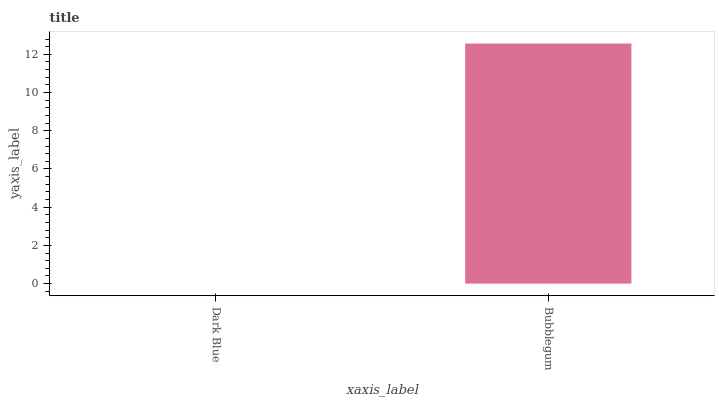Is Dark Blue the minimum?
Answer yes or no. Yes. Is Bubblegum the maximum?
Answer yes or no. Yes. Is Bubblegum the minimum?
Answer yes or no. No. Is Bubblegum greater than Dark Blue?
Answer yes or no. Yes. Is Dark Blue less than Bubblegum?
Answer yes or no. Yes. Is Dark Blue greater than Bubblegum?
Answer yes or no. No. Is Bubblegum less than Dark Blue?
Answer yes or no. No. Is Bubblegum the high median?
Answer yes or no. Yes. Is Dark Blue the low median?
Answer yes or no. Yes. Is Dark Blue the high median?
Answer yes or no. No. Is Bubblegum the low median?
Answer yes or no. No. 